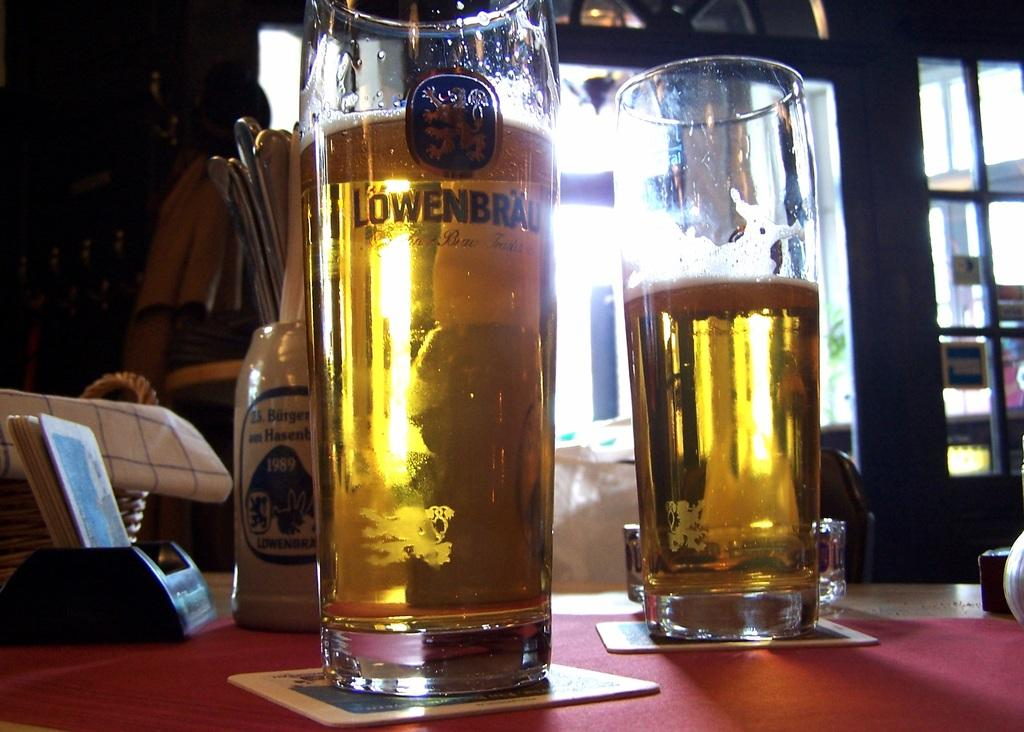<image>
Create a compact narrative representing the image presented. A large glass of Lowendrau is filled wth beer and sits on a bar. 